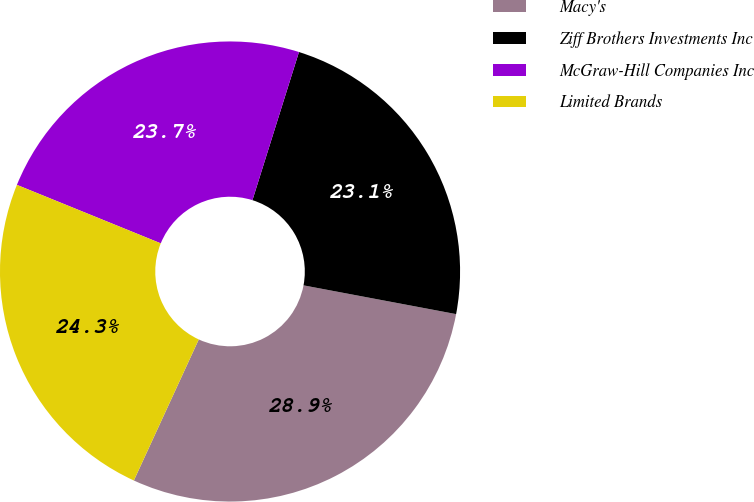Convert chart. <chart><loc_0><loc_0><loc_500><loc_500><pie_chart><fcel>Macy's<fcel>Ziff Brothers Investments Inc<fcel>McGraw-Hill Companies Inc<fcel>Limited Brands<nl><fcel>28.9%<fcel>23.12%<fcel>23.7%<fcel>24.28%<nl></chart> 